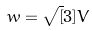Convert formula to latex. <formula><loc_0><loc_0><loc_500><loc_500>w = \sqrt { [ } 3 ] { V }</formula> 